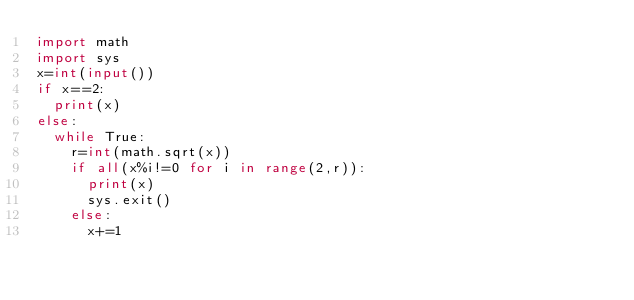Convert code to text. <code><loc_0><loc_0><loc_500><loc_500><_Python_>import math
import sys
x=int(input())
if x==2:
  print(x)
else:
  while True:
    r=int(math.sqrt(x))
    if all(x%i!=0 for i in range(2,r)):
      print(x)
      sys.exit()
    else:
      x+=1</code> 